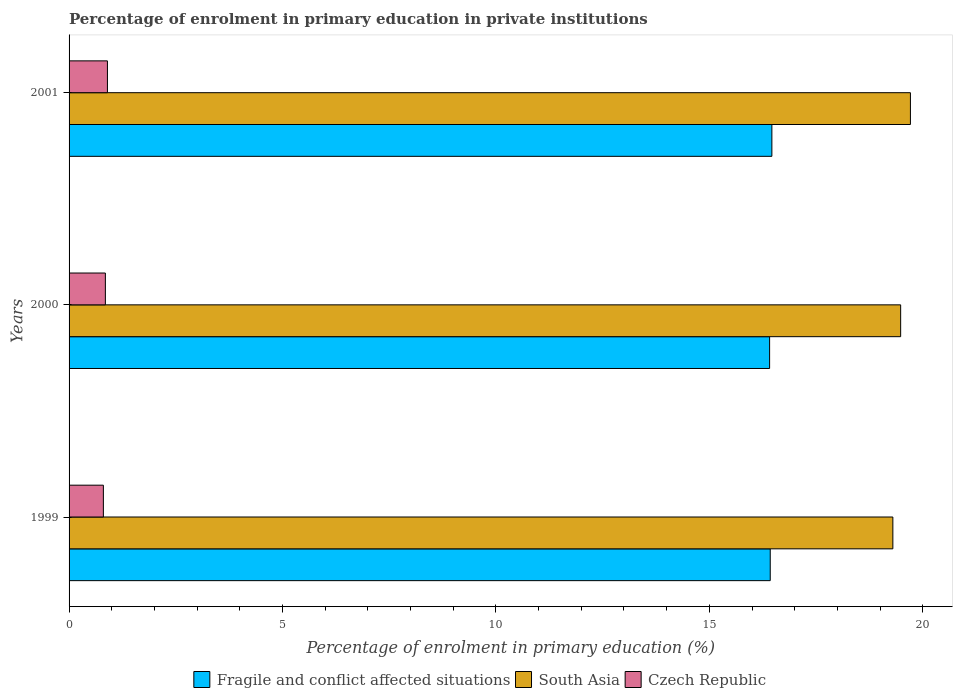Are the number of bars per tick equal to the number of legend labels?
Your answer should be compact. Yes. How many bars are there on the 2nd tick from the top?
Offer a very short reply. 3. How many bars are there on the 1st tick from the bottom?
Provide a short and direct response. 3. In how many cases, is the number of bars for a given year not equal to the number of legend labels?
Offer a very short reply. 0. What is the percentage of enrolment in primary education in Czech Republic in 1999?
Offer a terse response. 0.8. Across all years, what is the maximum percentage of enrolment in primary education in Fragile and conflict affected situations?
Your answer should be very brief. 16.47. Across all years, what is the minimum percentage of enrolment in primary education in Czech Republic?
Provide a succinct answer. 0.8. What is the total percentage of enrolment in primary education in South Asia in the graph?
Make the answer very short. 58.49. What is the difference between the percentage of enrolment in primary education in South Asia in 1999 and that in 2000?
Your answer should be compact. -0.18. What is the difference between the percentage of enrolment in primary education in Fragile and conflict affected situations in 2000 and the percentage of enrolment in primary education in South Asia in 1999?
Keep it short and to the point. -2.89. What is the average percentage of enrolment in primary education in Czech Republic per year?
Provide a succinct answer. 0.85. In the year 2001, what is the difference between the percentage of enrolment in primary education in Czech Republic and percentage of enrolment in primary education in Fragile and conflict affected situations?
Make the answer very short. -15.57. What is the ratio of the percentage of enrolment in primary education in South Asia in 1999 to that in 2000?
Provide a succinct answer. 0.99. Is the difference between the percentage of enrolment in primary education in Czech Republic in 1999 and 2001 greater than the difference between the percentage of enrolment in primary education in Fragile and conflict affected situations in 1999 and 2001?
Provide a short and direct response. No. What is the difference between the highest and the second highest percentage of enrolment in primary education in Fragile and conflict affected situations?
Your response must be concise. 0.04. What is the difference between the highest and the lowest percentage of enrolment in primary education in Czech Republic?
Keep it short and to the point. 0.1. What does the 3rd bar from the top in 2001 represents?
Your response must be concise. Fragile and conflict affected situations. What does the 1st bar from the bottom in 2000 represents?
Provide a short and direct response. Fragile and conflict affected situations. What is the difference between two consecutive major ticks on the X-axis?
Your response must be concise. 5. Are the values on the major ticks of X-axis written in scientific E-notation?
Offer a terse response. No. Does the graph contain any zero values?
Give a very brief answer. No. How are the legend labels stacked?
Your response must be concise. Horizontal. What is the title of the graph?
Ensure brevity in your answer.  Percentage of enrolment in primary education in private institutions. Does "Cyprus" appear as one of the legend labels in the graph?
Give a very brief answer. No. What is the label or title of the X-axis?
Ensure brevity in your answer.  Percentage of enrolment in primary education (%). What is the label or title of the Y-axis?
Make the answer very short. Years. What is the Percentage of enrolment in primary education (%) in Fragile and conflict affected situations in 1999?
Ensure brevity in your answer.  16.43. What is the Percentage of enrolment in primary education (%) of South Asia in 1999?
Your answer should be compact. 19.3. What is the Percentage of enrolment in primary education (%) of Czech Republic in 1999?
Your answer should be compact. 0.8. What is the Percentage of enrolment in primary education (%) in Fragile and conflict affected situations in 2000?
Make the answer very short. 16.41. What is the Percentage of enrolment in primary education (%) in South Asia in 2000?
Offer a very short reply. 19.48. What is the Percentage of enrolment in primary education (%) of Czech Republic in 2000?
Ensure brevity in your answer.  0.85. What is the Percentage of enrolment in primary education (%) of Fragile and conflict affected situations in 2001?
Your answer should be compact. 16.47. What is the Percentage of enrolment in primary education (%) of South Asia in 2001?
Your response must be concise. 19.71. What is the Percentage of enrolment in primary education (%) of Czech Republic in 2001?
Offer a terse response. 0.9. Across all years, what is the maximum Percentage of enrolment in primary education (%) in Fragile and conflict affected situations?
Your answer should be very brief. 16.47. Across all years, what is the maximum Percentage of enrolment in primary education (%) in South Asia?
Offer a very short reply. 19.71. Across all years, what is the maximum Percentage of enrolment in primary education (%) of Czech Republic?
Provide a short and direct response. 0.9. Across all years, what is the minimum Percentage of enrolment in primary education (%) of Fragile and conflict affected situations?
Ensure brevity in your answer.  16.41. Across all years, what is the minimum Percentage of enrolment in primary education (%) of South Asia?
Your response must be concise. 19.3. Across all years, what is the minimum Percentage of enrolment in primary education (%) in Czech Republic?
Offer a very short reply. 0.8. What is the total Percentage of enrolment in primary education (%) in Fragile and conflict affected situations in the graph?
Provide a succinct answer. 49.3. What is the total Percentage of enrolment in primary education (%) in South Asia in the graph?
Offer a terse response. 58.49. What is the total Percentage of enrolment in primary education (%) of Czech Republic in the graph?
Offer a terse response. 2.55. What is the difference between the Percentage of enrolment in primary education (%) of Fragile and conflict affected situations in 1999 and that in 2000?
Provide a short and direct response. 0.01. What is the difference between the Percentage of enrolment in primary education (%) of South Asia in 1999 and that in 2000?
Provide a short and direct response. -0.18. What is the difference between the Percentage of enrolment in primary education (%) in Czech Republic in 1999 and that in 2000?
Your answer should be compact. -0.05. What is the difference between the Percentage of enrolment in primary education (%) in Fragile and conflict affected situations in 1999 and that in 2001?
Your response must be concise. -0.04. What is the difference between the Percentage of enrolment in primary education (%) in South Asia in 1999 and that in 2001?
Your answer should be compact. -0.41. What is the difference between the Percentage of enrolment in primary education (%) in Czech Republic in 1999 and that in 2001?
Your answer should be compact. -0.1. What is the difference between the Percentage of enrolment in primary education (%) of Fragile and conflict affected situations in 2000 and that in 2001?
Offer a very short reply. -0.05. What is the difference between the Percentage of enrolment in primary education (%) in South Asia in 2000 and that in 2001?
Your response must be concise. -0.23. What is the difference between the Percentage of enrolment in primary education (%) of Czech Republic in 2000 and that in 2001?
Make the answer very short. -0.05. What is the difference between the Percentage of enrolment in primary education (%) in Fragile and conflict affected situations in 1999 and the Percentage of enrolment in primary education (%) in South Asia in 2000?
Offer a terse response. -3.06. What is the difference between the Percentage of enrolment in primary education (%) of Fragile and conflict affected situations in 1999 and the Percentage of enrolment in primary education (%) of Czech Republic in 2000?
Offer a very short reply. 15.58. What is the difference between the Percentage of enrolment in primary education (%) of South Asia in 1999 and the Percentage of enrolment in primary education (%) of Czech Republic in 2000?
Offer a very short reply. 18.45. What is the difference between the Percentage of enrolment in primary education (%) of Fragile and conflict affected situations in 1999 and the Percentage of enrolment in primary education (%) of South Asia in 2001?
Offer a very short reply. -3.28. What is the difference between the Percentage of enrolment in primary education (%) in Fragile and conflict affected situations in 1999 and the Percentage of enrolment in primary education (%) in Czech Republic in 2001?
Provide a short and direct response. 15.53. What is the difference between the Percentage of enrolment in primary education (%) in South Asia in 1999 and the Percentage of enrolment in primary education (%) in Czech Republic in 2001?
Provide a succinct answer. 18.4. What is the difference between the Percentage of enrolment in primary education (%) in Fragile and conflict affected situations in 2000 and the Percentage of enrolment in primary education (%) in South Asia in 2001?
Keep it short and to the point. -3.3. What is the difference between the Percentage of enrolment in primary education (%) of Fragile and conflict affected situations in 2000 and the Percentage of enrolment in primary education (%) of Czech Republic in 2001?
Keep it short and to the point. 15.51. What is the difference between the Percentage of enrolment in primary education (%) of South Asia in 2000 and the Percentage of enrolment in primary education (%) of Czech Republic in 2001?
Offer a terse response. 18.58. What is the average Percentage of enrolment in primary education (%) of Fragile and conflict affected situations per year?
Your answer should be compact. 16.43. What is the average Percentage of enrolment in primary education (%) of South Asia per year?
Your answer should be compact. 19.5. What is the average Percentage of enrolment in primary education (%) of Czech Republic per year?
Provide a short and direct response. 0.85. In the year 1999, what is the difference between the Percentage of enrolment in primary education (%) of Fragile and conflict affected situations and Percentage of enrolment in primary education (%) of South Asia?
Provide a succinct answer. -2.87. In the year 1999, what is the difference between the Percentage of enrolment in primary education (%) of Fragile and conflict affected situations and Percentage of enrolment in primary education (%) of Czech Republic?
Give a very brief answer. 15.62. In the year 1999, what is the difference between the Percentage of enrolment in primary education (%) in South Asia and Percentage of enrolment in primary education (%) in Czech Republic?
Make the answer very short. 18.5. In the year 2000, what is the difference between the Percentage of enrolment in primary education (%) of Fragile and conflict affected situations and Percentage of enrolment in primary education (%) of South Asia?
Your answer should be very brief. -3.07. In the year 2000, what is the difference between the Percentage of enrolment in primary education (%) of Fragile and conflict affected situations and Percentage of enrolment in primary education (%) of Czech Republic?
Provide a short and direct response. 15.56. In the year 2000, what is the difference between the Percentage of enrolment in primary education (%) of South Asia and Percentage of enrolment in primary education (%) of Czech Republic?
Offer a very short reply. 18.63. In the year 2001, what is the difference between the Percentage of enrolment in primary education (%) in Fragile and conflict affected situations and Percentage of enrolment in primary education (%) in South Asia?
Your answer should be compact. -3.25. In the year 2001, what is the difference between the Percentage of enrolment in primary education (%) in Fragile and conflict affected situations and Percentage of enrolment in primary education (%) in Czech Republic?
Provide a succinct answer. 15.57. In the year 2001, what is the difference between the Percentage of enrolment in primary education (%) in South Asia and Percentage of enrolment in primary education (%) in Czech Republic?
Provide a short and direct response. 18.81. What is the ratio of the Percentage of enrolment in primary education (%) of Fragile and conflict affected situations in 1999 to that in 2000?
Ensure brevity in your answer.  1. What is the ratio of the Percentage of enrolment in primary education (%) in South Asia in 1999 to that in 2000?
Keep it short and to the point. 0.99. What is the ratio of the Percentage of enrolment in primary education (%) of Czech Republic in 1999 to that in 2000?
Ensure brevity in your answer.  0.94. What is the ratio of the Percentage of enrolment in primary education (%) of South Asia in 1999 to that in 2001?
Your answer should be compact. 0.98. What is the ratio of the Percentage of enrolment in primary education (%) of Czech Republic in 1999 to that in 2001?
Give a very brief answer. 0.89. What is the ratio of the Percentage of enrolment in primary education (%) in Fragile and conflict affected situations in 2000 to that in 2001?
Keep it short and to the point. 1. What is the ratio of the Percentage of enrolment in primary education (%) in South Asia in 2000 to that in 2001?
Provide a short and direct response. 0.99. What is the ratio of the Percentage of enrolment in primary education (%) of Czech Republic in 2000 to that in 2001?
Your answer should be very brief. 0.95. What is the difference between the highest and the second highest Percentage of enrolment in primary education (%) in Fragile and conflict affected situations?
Ensure brevity in your answer.  0.04. What is the difference between the highest and the second highest Percentage of enrolment in primary education (%) in South Asia?
Give a very brief answer. 0.23. What is the difference between the highest and the second highest Percentage of enrolment in primary education (%) in Czech Republic?
Provide a short and direct response. 0.05. What is the difference between the highest and the lowest Percentage of enrolment in primary education (%) in Fragile and conflict affected situations?
Your response must be concise. 0.05. What is the difference between the highest and the lowest Percentage of enrolment in primary education (%) of South Asia?
Give a very brief answer. 0.41. What is the difference between the highest and the lowest Percentage of enrolment in primary education (%) of Czech Republic?
Make the answer very short. 0.1. 